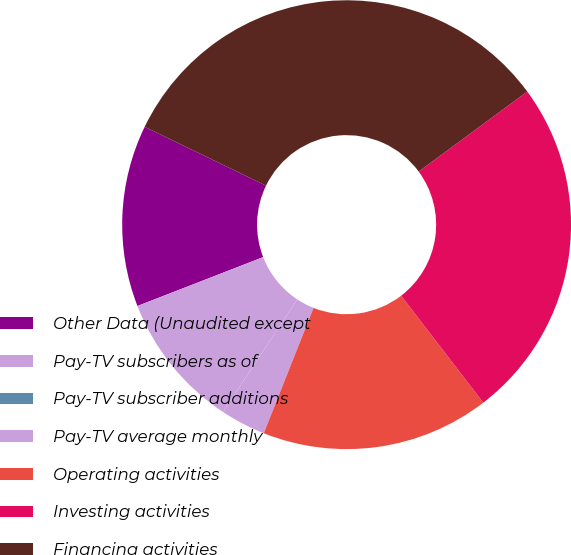Convert chart. <chart><loc_0><loc_0><loc_500><loc_500><pie_chart><fcel>Other Data (Unaudited except<fcel>Pay-TV subscribers as of<fcel>Pay-TV subscriber additions<fcel>Pay-TV average monthly<fcel>Operating activities<fcel>Investing activities<fcel>Financing activities<nl><fcel>13.08%<fcel>9.81%<fcel>0.0%<fcel>3.27%<fcel>16.44%<fcel>24.68%<fcel>32.71%<nl></chart> 